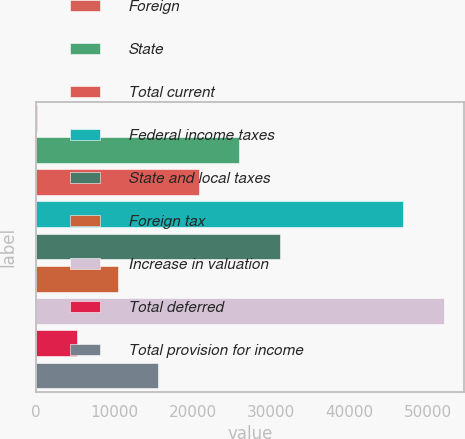Convert chart to OTSL. <chart><loc_0><loc_0><loc_500><loc_500><bar_chart><fcel>Foreign<fcel>State<fcel>Total current<fcel>Federal income taxes<fcel>State and local taxes<fcel>Foreign tax<fcel>Increase in valuation<fcel>Total deferred<fcel>Total provision for income<nl><fcel>69<fcel>25909<fcel>20741<fcel>46835<fcel>31077<fcel>10405<fcel>52003<fcel>5237<fcel>15573<nl></chart> 